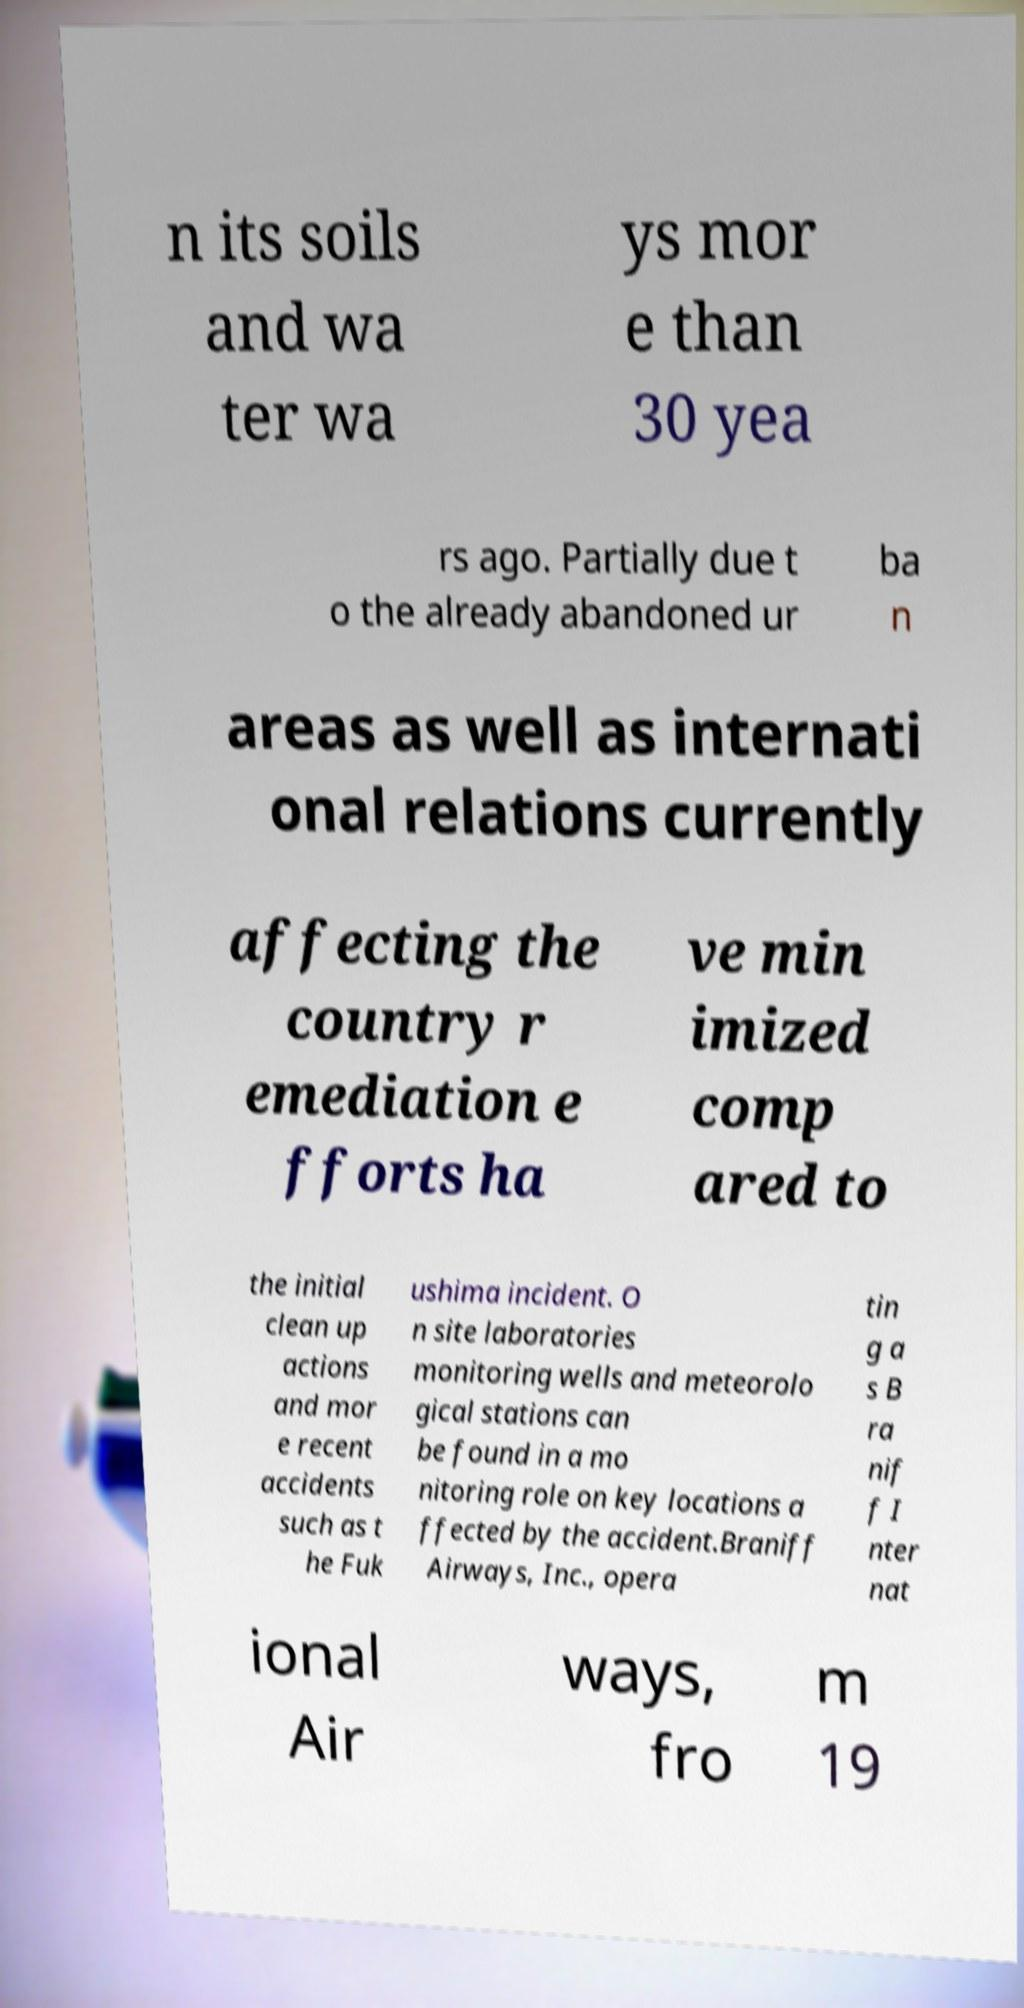There's text embedded in this image that I need extracted. Can you transcribe it verbatim? n its soils and wa ter wa ys mor e than 30 yea rs ago. Partially due t o the already abandoned ur ba n areas as well as internati onal relations currently affecting the country r emediation e fforts ha ve min imized comp ared to the initial clean up actions and mor e recent accidents such as t he Fuk ushima incident. O n site laboratories monitoring wells and meteorolo gical stations can be found in a mo nitoring role on key locations a ffected by the accident.Braniff Airways, Inc., opera tin g a s B ra nif f I nter nat ional Air ways, fro m 19 